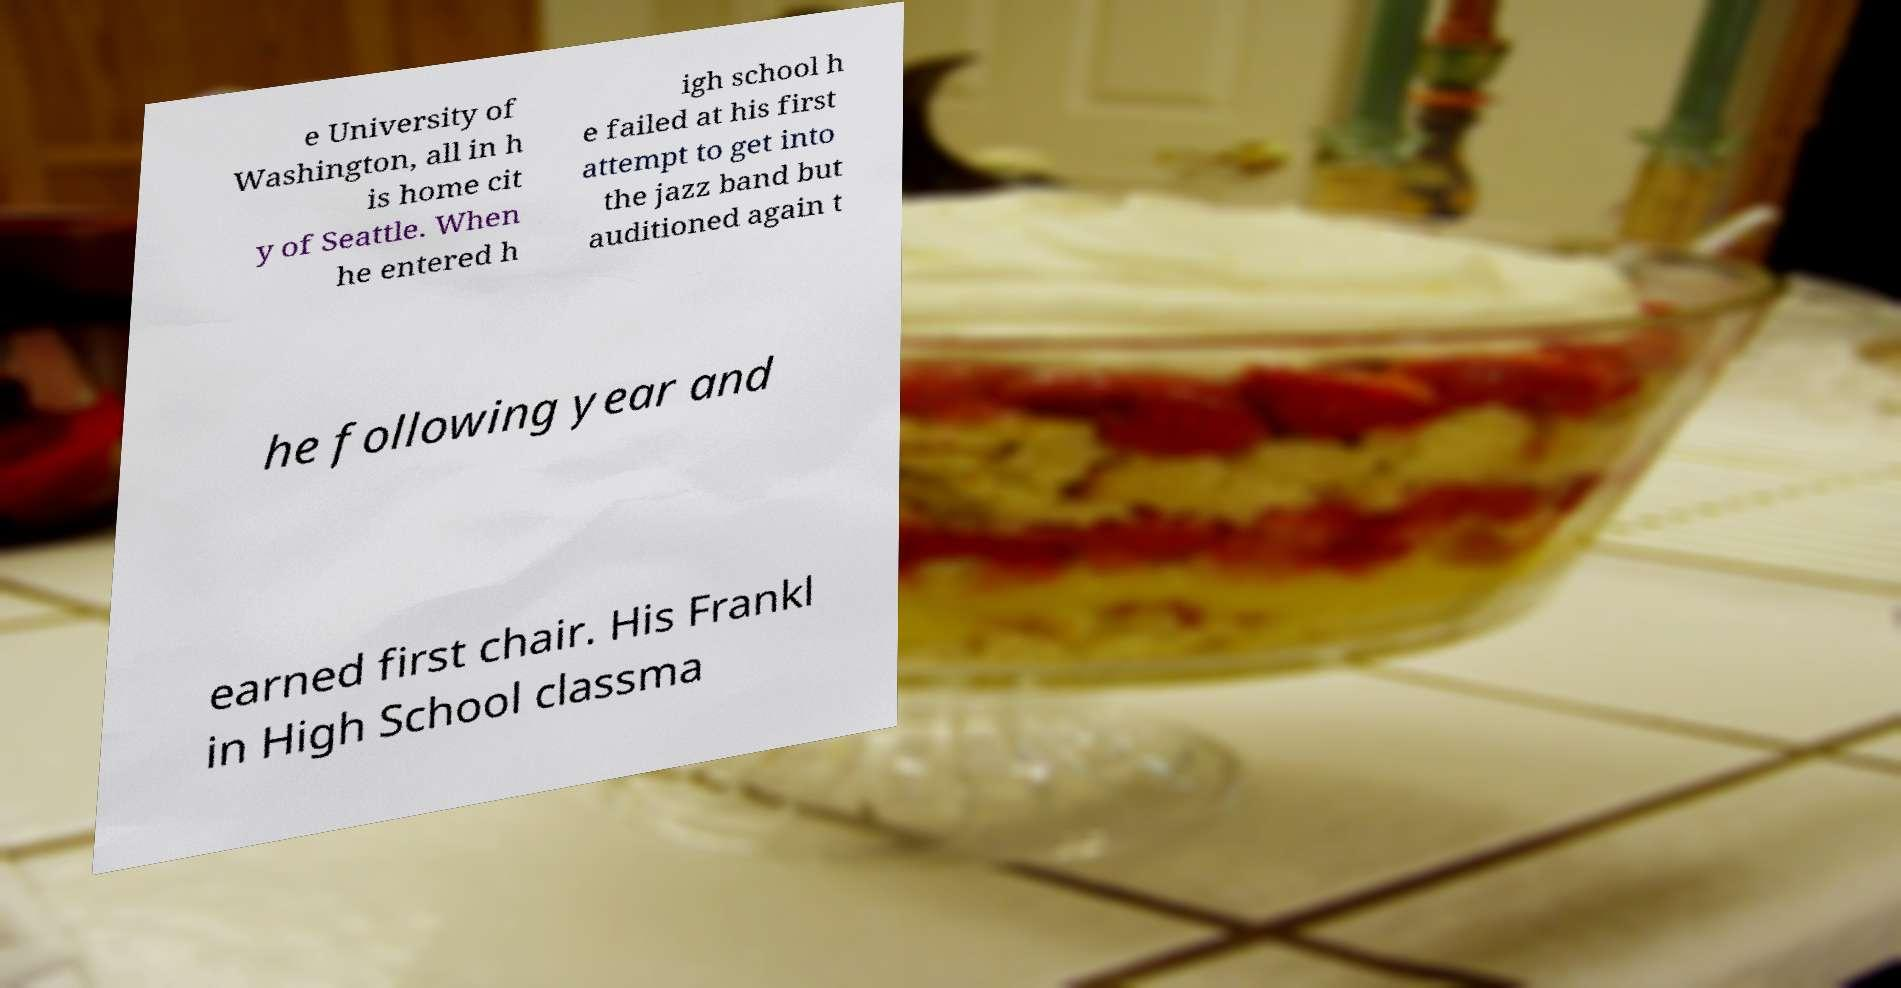Please identify and transcribe the text found in this image. e University of Washington, all in h is home cit y of Seattle. When he entered h igh school h e failed at his first attempt to get into the jazz band but auditioned again t he following year and earned first chair. His Frankl in High School classma 